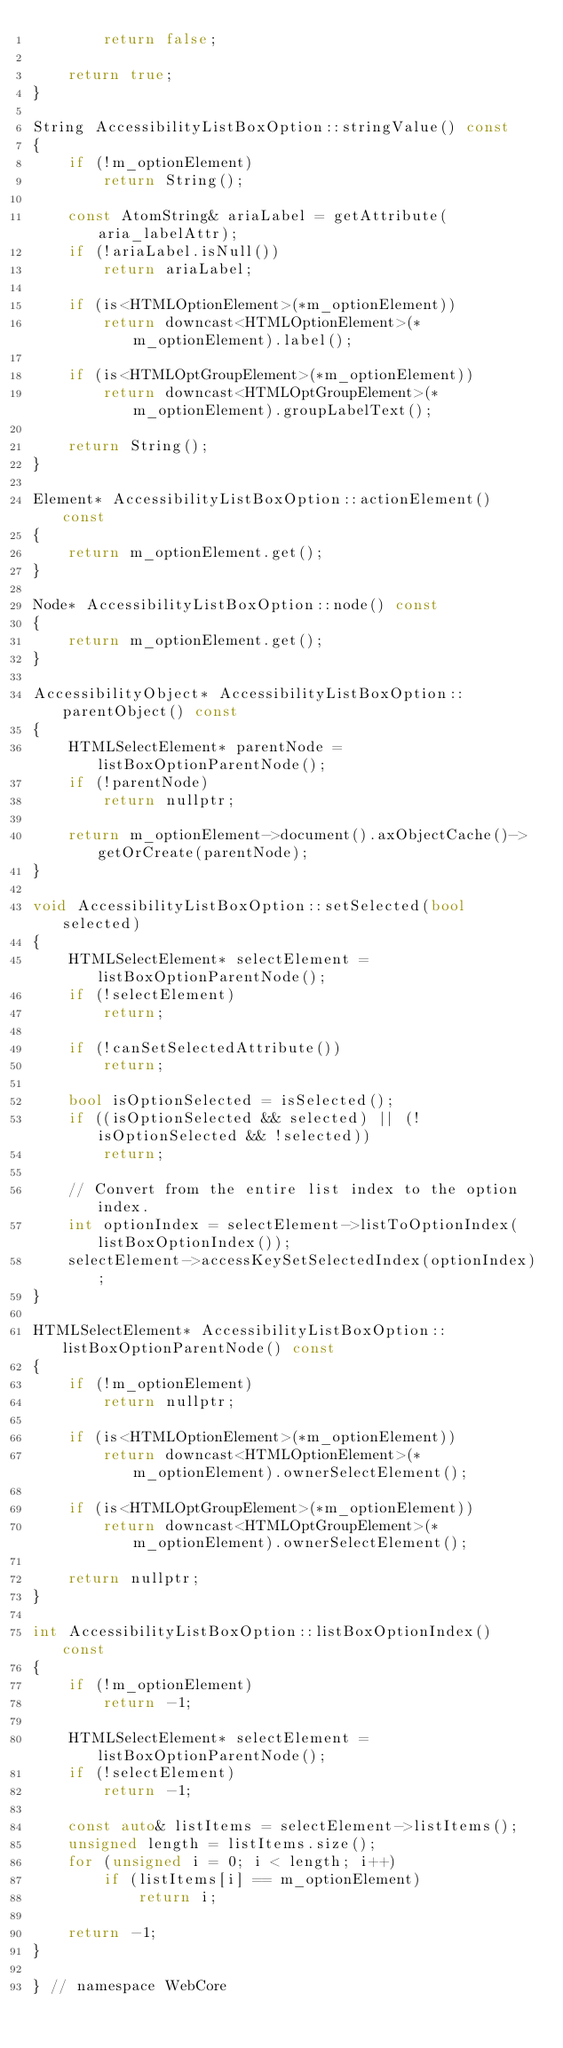Convert code to text. <code><loc_0><loc_0><loc_500><loc_500><_C++_>        return false;
    
    return true;
}
    
String AccessibilityListBoxOption::stringValue() const
{
    if (!m_optionElement)
        return String();
    
    const AtomString& ariaLabel = getAttribute(aria_labelAttr);
    if (!ariaLabel.isNull())
        return ariaLabel;
    
    if (is<HTMLOptionElement>(*m_optionElement))
        return downcast<HTMLOptionElement>(*m_optionElement).label();
    
    if (is<HTMLOptGroupElement>(*m_optionElement))
        return downcast<HTMLOptGroupElement>(*m_optionElement).groupLabelText();
    
    return String();
}

Element* AccessibilityListBoxOption::actionElement() const
{
    return m_optionElement.get();
}

Node* AccessibilityListBoxOption::node() const
{
    return m_optionElement.get();
}

AccessibilityObject* AccessibilityListBoxOption::parentObject() const
{
    HTMLSelectElement* parentNode = listBoxOptionParentNode();
    if (!parentNode)
        return nullptr;
    
    return m_optionElement->document().axObjectCache()->getOrCreate(parentNode);
}

void AccessibilityListBoxOption::setSelected(bool selected)
{
    HTMLSelectElement* selectElement = listBoxOptionParentNode();
    if (!selectElement)
        return;
    
    if (!canSetSelectedAttribute())
        return;
    
    bool isOptionSelected = isSelected();
    if ((isOptionSelected && selected) || (!isOptionSelected && !selected))
        return;
    
    // Convert from the entire list index to the option index.
    int optionIndex = selectElement->listToOptionIndex(listBoxOptionIndex());
    selectElement->accessKeySetSelectedIndex(optionIndex);
}

HTMLSelectElement* AccessibilityListBoxOption::listBoxOptionParentNode() const
{
    if (!m_optionElement)
        return nullptr;

    if (is<HTMLOptionElement>(*m_optionElement))
        return downcast<HTMLOptionElement>(*m_optionElement).ownerSelectElement();

    if (is<HTMLOptGroupElement>(*m_optionElement))
        return downcast<HTMLOptGroupElement>(*m_optionElement).ownerSelectElement();

    return nullptr;
}

int AccessibilityListBoxOption::listBoxOptionIndex() const
{
    if (!m_optionElement)
        return -1;
    
    HTMLSelectElement* selectElement = listBoxOptionParentNode();
    if (!selectElement) 
        return -1;
    
    const auto& listItems = selectElement->listItems();
    unsigned length = listItems.size();
    for (unsigned i = 0; i < length; i++)
        if (listItems[i] == m_optionElement)
            return i;

    return -1;
}

} // namespace WebCore
</code> 